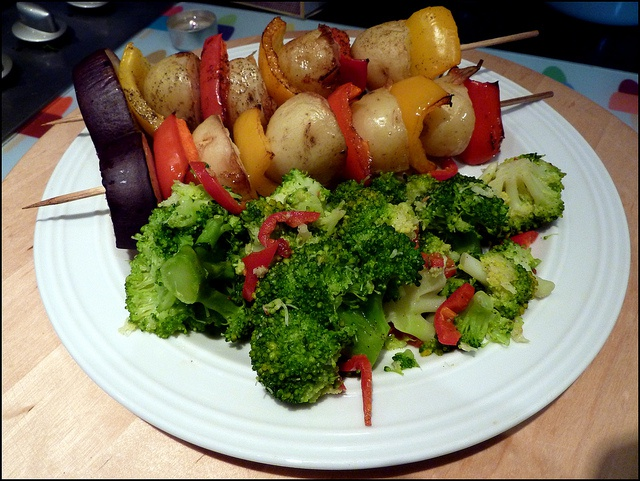Describe the objects in this image and their specific colors. I can see broccoli in black, darkgreen, and olive tones and broccoli in black, darkgreen, and olive tones in this image. 